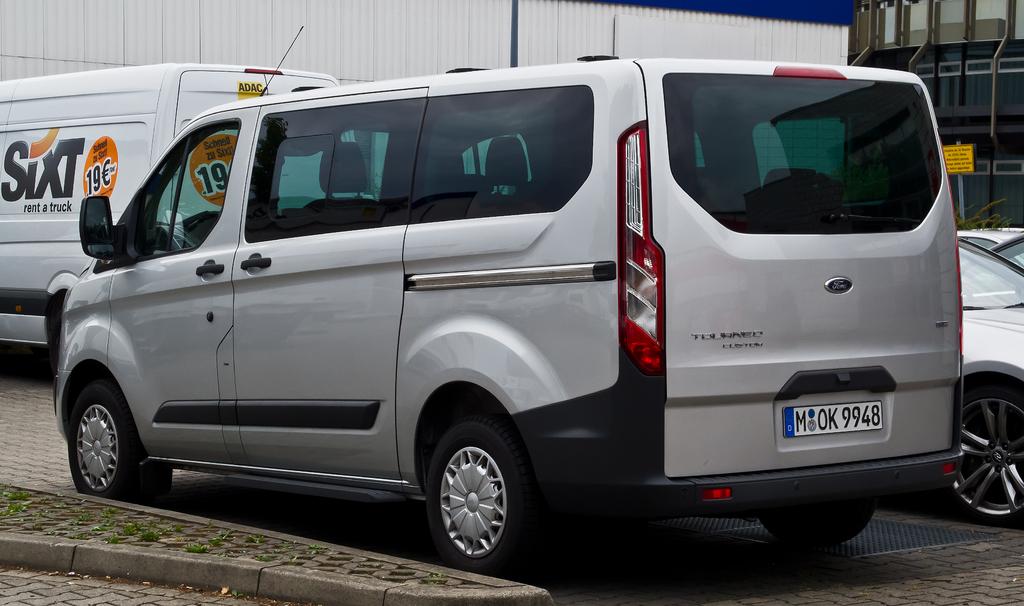What is the licence number of the truck?
Your response must be concise. M ok 9948. What brand is this van?
Make the answer very short. Ford. 